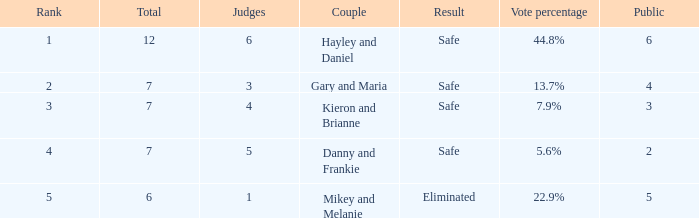How many judges were there for the eliminated couple?  1.0. 